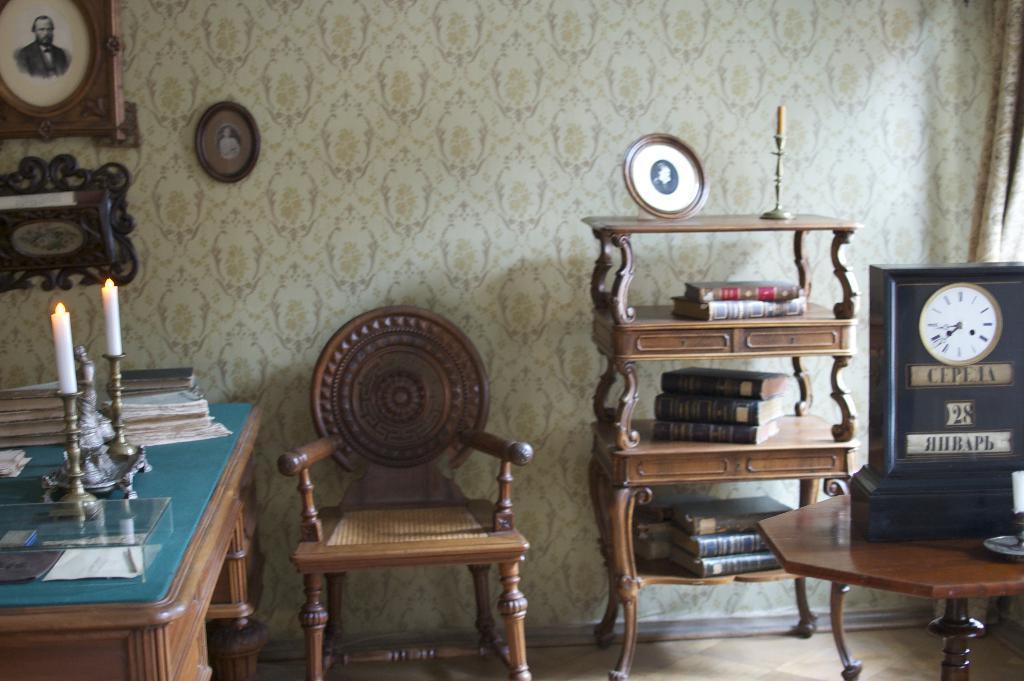How would you summarize this image in a sentence or two? As we can see in the image, there are photo frames, chair, table. On table there are books and candles and on the right side there is a book and a rack. 